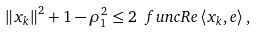<formula> <loc_0><loc_0><loc_500><loc_500>\left \| x _ { k } \right \| ^ { 2 } + 1 - \rho _ { 1 } ^ { 2 } \leq 2 \ f u n c { R e } \left \langle x _ { k } , e \right \rangle ,</formula> 